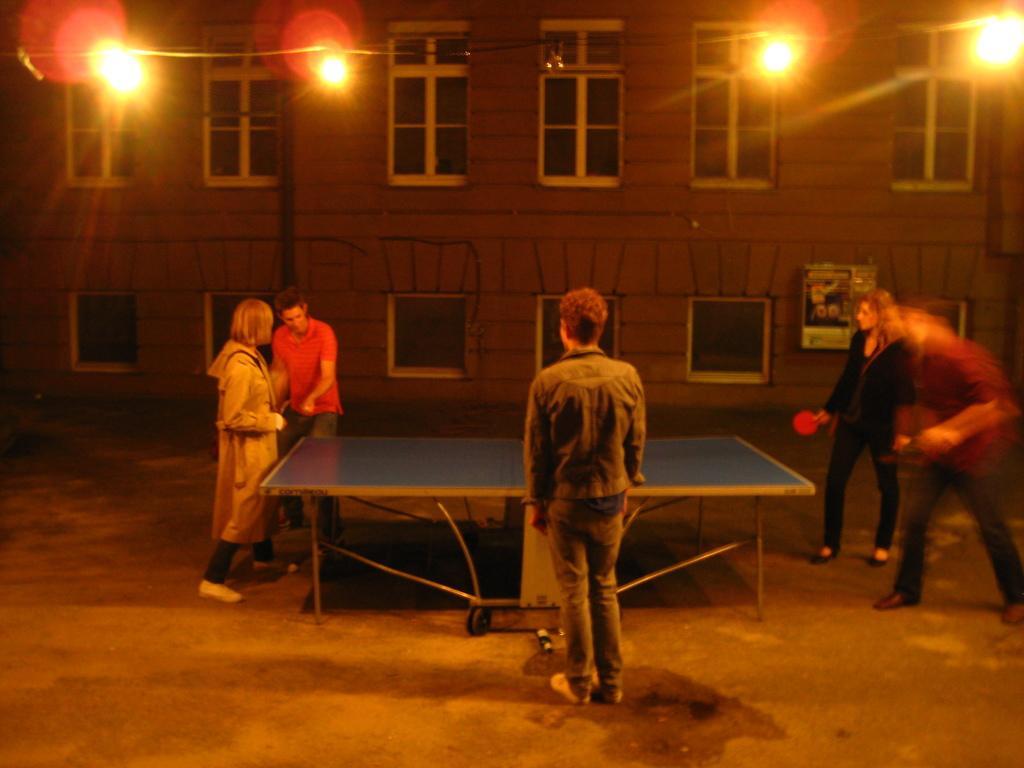How would you summarize this image in a sentence or two? In this picture there are people standing, among them there is a person holding a bat and we can see table on the surface. In the background of the image we can see lights, poles, wall and windows. 